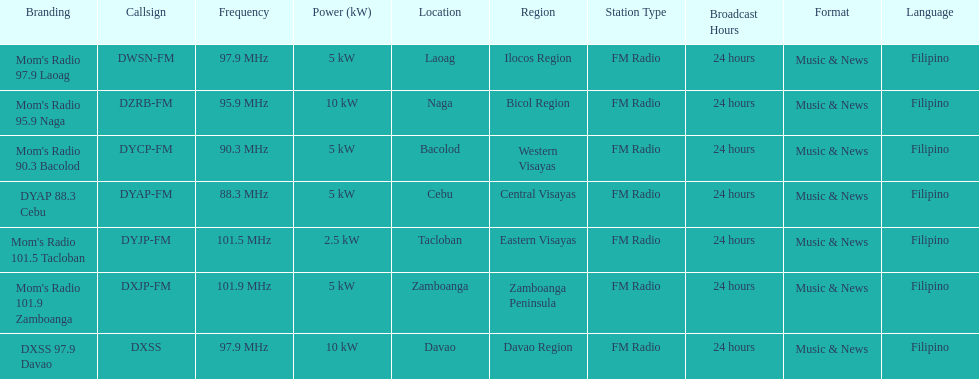What is the radio with the least about of mhz? DYAP 88.3 Cebu. 